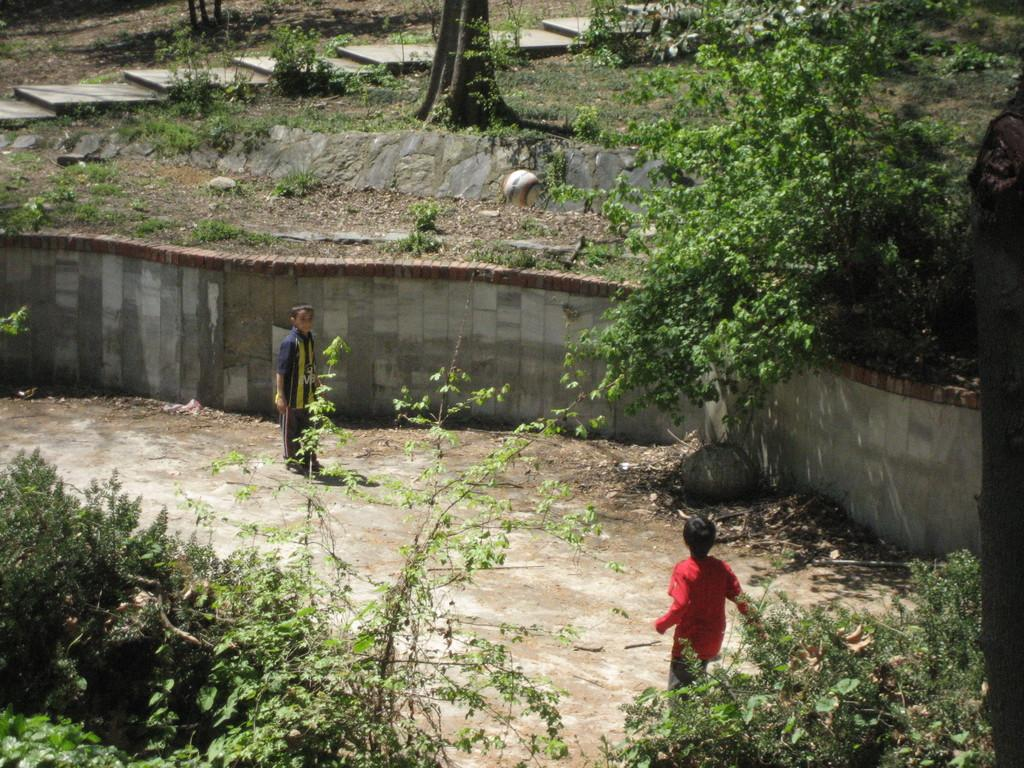What is present in the image that serves as a background or boundary? There is a wall in the image. How many people can be seen in the image? There are two people in the image. What type of vegetation is visible in the image? There are plants and trees in the image. What type of rice can be seen growing in the image? There is no rice present in the image. Where is the patch of land located in the image? There is no patch of land mentioned in the provided facts; the image only includes a wall, two people, plants, and trees. 